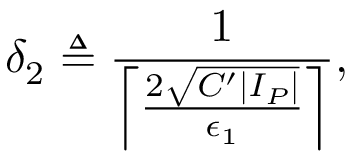<formula> <loc_0><loc_0><loc_500><loc_500>\delta _ { 2 } \triangle q \frac { 1 } { \left \lceil \frac { 2 \sqrt { C ^ { \prime } | I _ { P } | } } { \epsilon _ { 1 } } \right \rceil } ,</formula> 